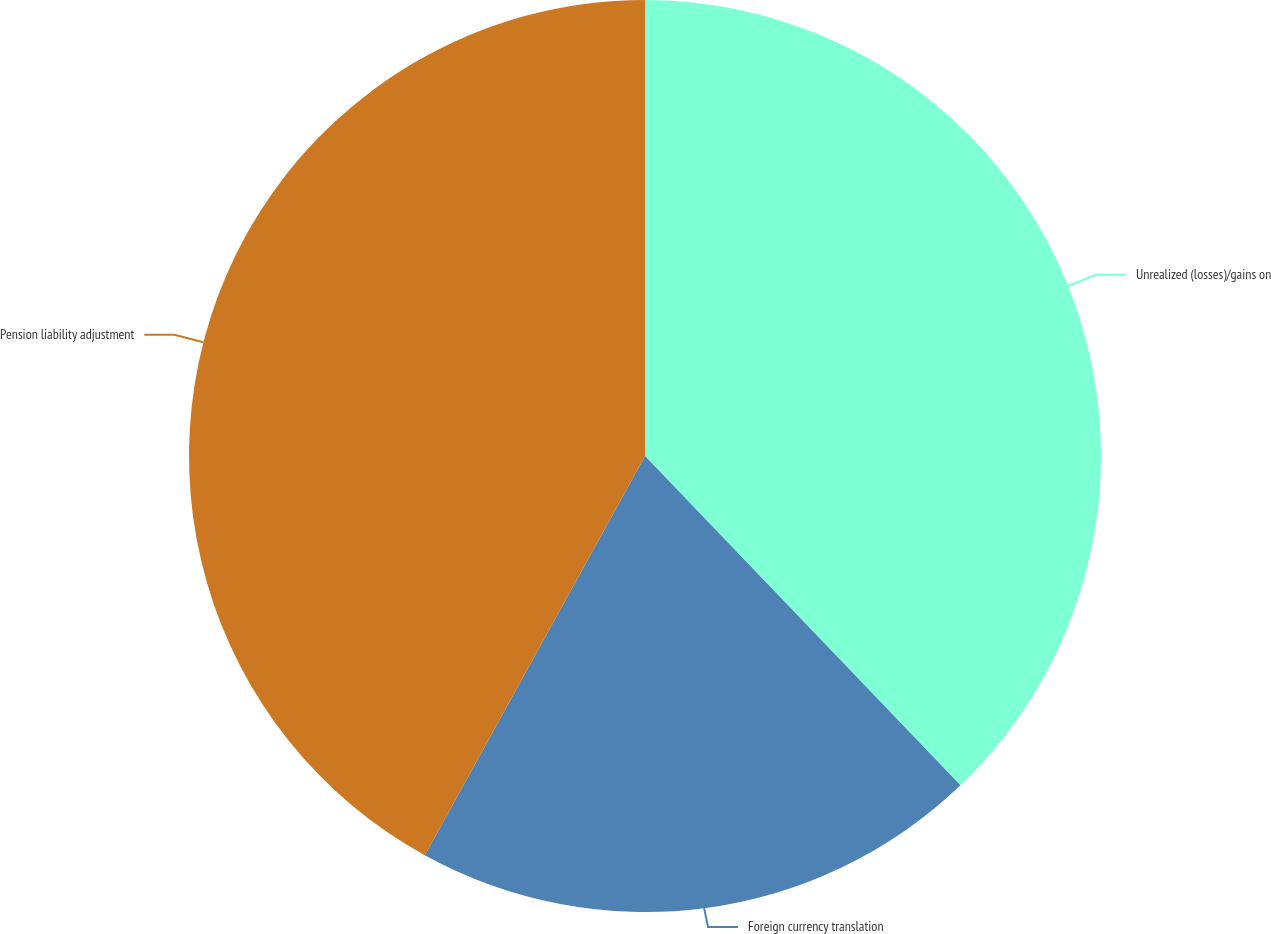Convert chart to OTSL. <chart><loc_0><loc_0><loc_500><loc_500><pie_chart><fcel>Unrealized (losses)/gains on<fcel>Foreign currency translation<fcel>Pension liability adjustment<nl><fcel>37.84%<fcel>20.18%<fcel>41.98%<nl></chart> 